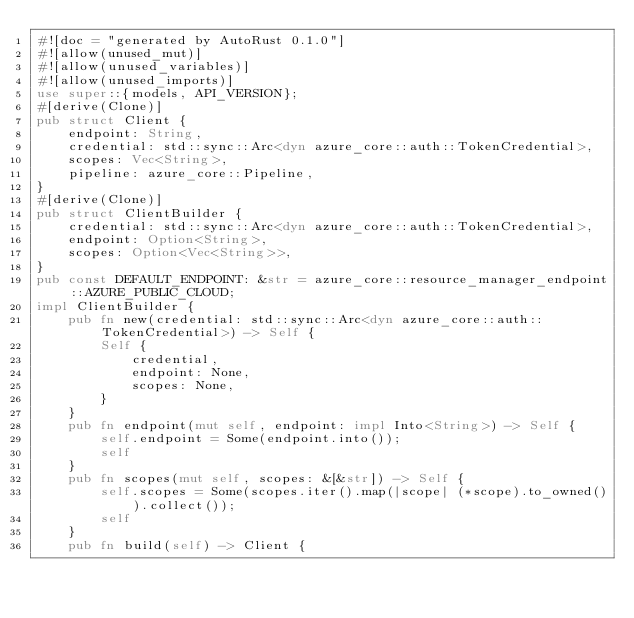<code> <loc_0><loc_0><loc_500><loc_500><_Rust_>#![doc = "generated by AutoRust 0.1.0"]
#![allow(unused_mut)]
#![allow(unused_variables)]
#![allow(unused_imports)]
use super::{models, API_VERSION};
#[derive(Clone)]
pub struct Client {
    endpoint: String,
    credential: std::sync::Arc<dyn azure_core::auth::TokenCredential>,
    scopes: Vec<String>,
    pipeline: azure_core::Pipeline,
}
#[derive(Clone)]
pub struct ClientBuilder {
    credential: std::sync::Arc<dyn azure_core::auth::TokenCredential>,
    endpoint: Option<String>,
    scopes: Option<Vec<String>>,
}
pub const DEFAULT_ENDPOINT: &str = azure_core::resource_manager_endpoint::AZURE_PUBLIC_CLOUD;
impl ClientBuilder {
    pub fn new(credential: std::sync::Arc<dyn azure_core::auth::TokenCredential>) -> Self {
        Self {
            credential,
            endpoint: None,
            scopes: None,
        }
    }
    pub fn endpoint(mut self, endpoint: impl Into<String>) -> Self {
        self.endpoint = Some(endpoint.into());
        self
    }
    pub fn scopes(mut self, scopes: &[&str]) -> Self {
        self.scopes = Some(scopes.iter().map(|scope| (*scope).to_owned()).collect());
        self
    }
    pub fn build(self) -> Client {</code> 